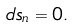Convert formula to latex. <formula><loc_0><loc_0><loc_500><loc_500>d s _ { n } = 0 .</formula> 